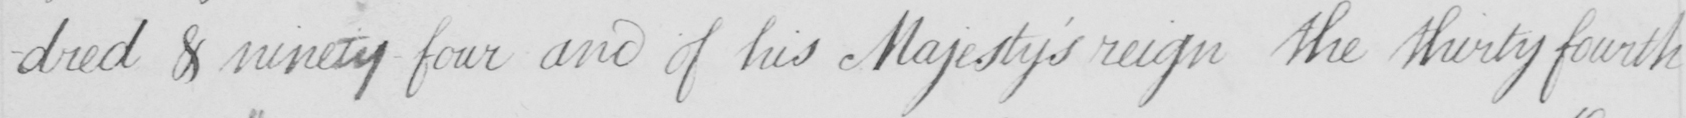Please transcribe the handwritten text in this image. -dred & ninety four and his Majesty ' s reign the thirty fourth 